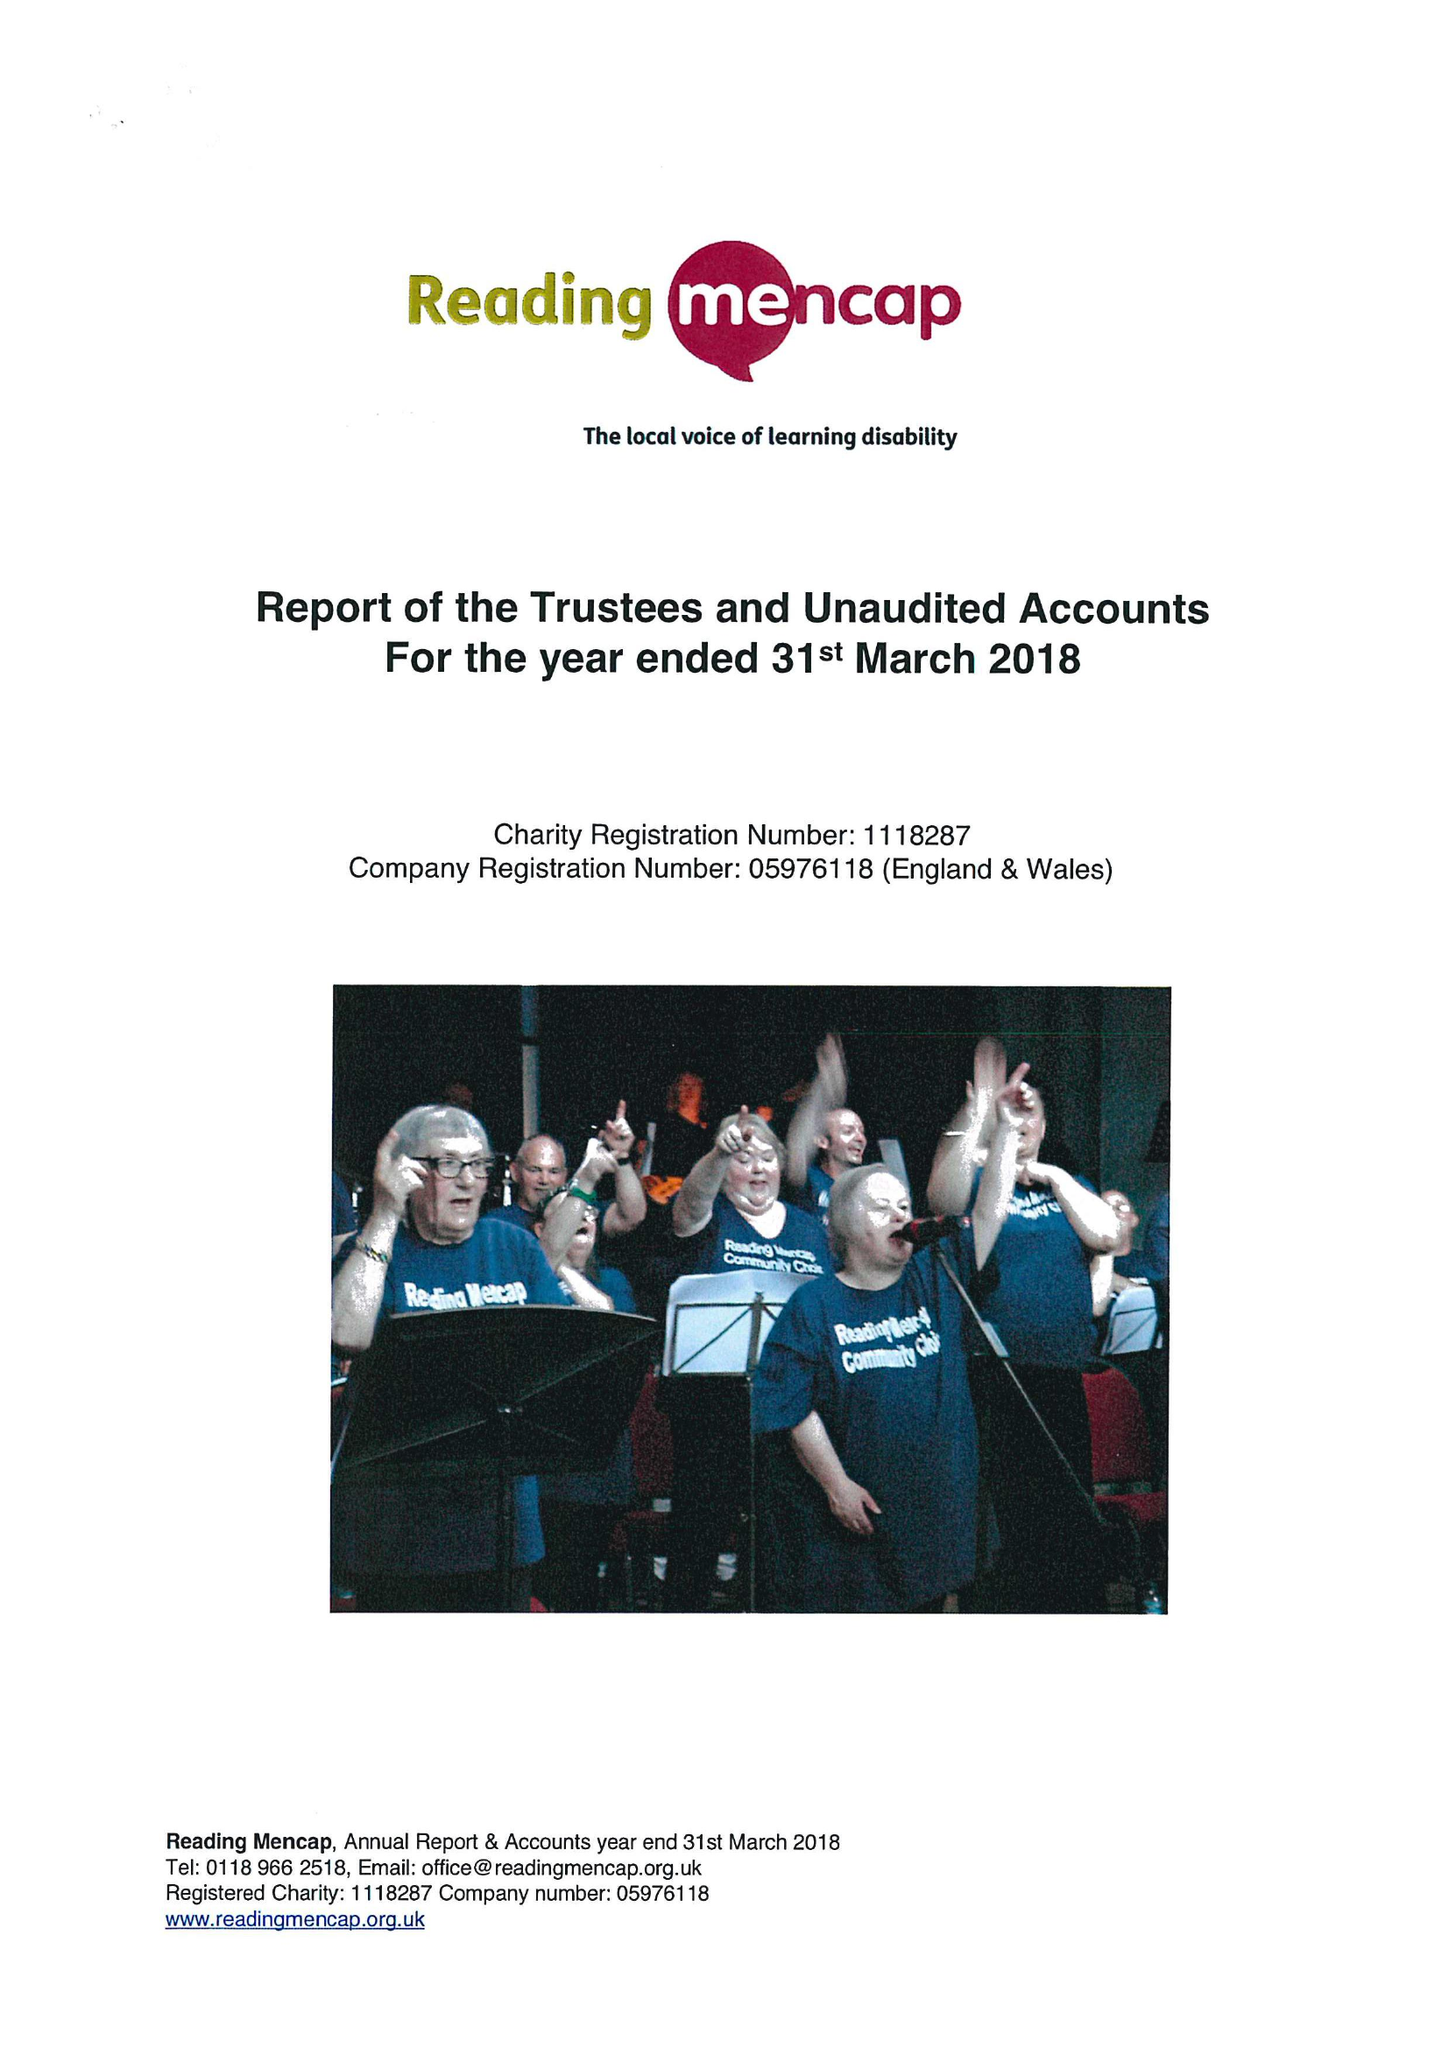What is the value for the address__post_town?
Answer the question using a single word or phrase. READING 